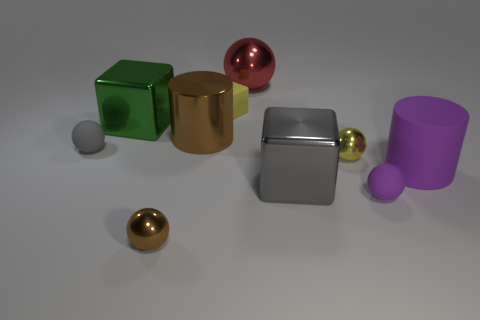Subtract all large blocks. How many blocks are left? 1 Subtract all brown spheres. How many spheres are left? 4 Subtract all blocks. How many objects are left? 7 Add 8 tiny yellow spheres. How many tiny yellow spheres exist? 9 Subtract 0 brown cubes. How many objects are left? 10 Subtract 2 balls. How many balls are left? 3 Subtract all blue blocks. Subtract all blue cylinders. How many blocks are left? 3 Subtract all green balls. How many brown blocks are left? 0 Subtract all tiny yellow spheres. Subtract all small gray matte spheres. How many objects are left? 8 Add 8 big cubes. How many big cubes are left? 10 